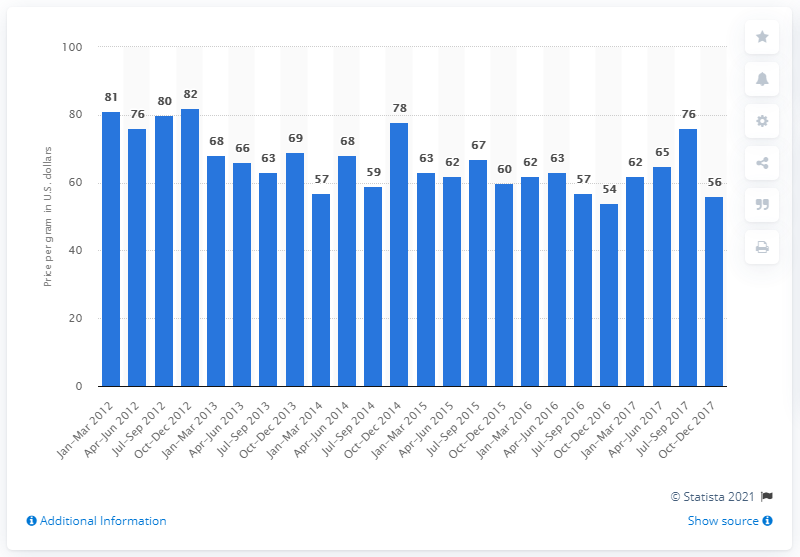Indicate a few pertinent items in this graphic. In the fourth quarter of 2012, the average price per gram for pure methamphetamine in the United States was 54 dollars. In the third quarter of 2017, the price per gram for pure methamphetamine was 76.. 